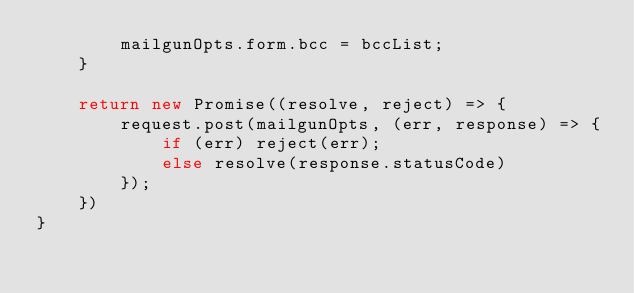<code> <loc_0><loc_0><loc_500><loc_500><_JavaScript_>        mailgunOpts.form.bcc = bccList;
    }

    return new Promise((resolve, reject) => {
        request.post(mailgunOpts, (err, response) => {
            if (err) reject(err);
            else resolve(response.statusCode)
        });
    })
}</code> 